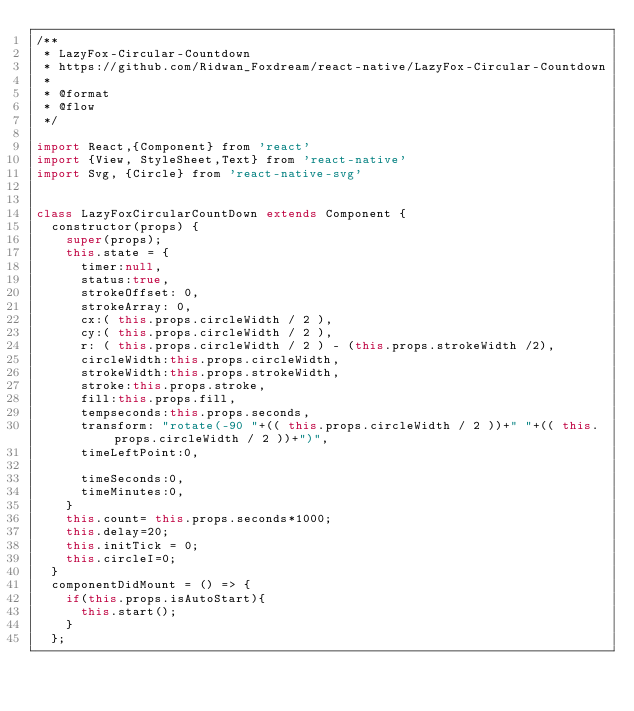<code> <loc_0><loc_0><loc_500><loc_500><_JavaScript_>/**
 * LazyFox-Circular-Countdown
 * https://github.com/Ridwan_Foxdream/react-native/LazyFox-Circular-Countdown
 *
 * @format
 * @flow
 */

import React,{Component} from 'react'
import {View, StyleSheet,Text} from 'react-native'
import Svg, {Circle} from 'react-native-svg'


class LazyFoxCircularCountDown extends Component {
  constructor(props) {
    super(props);
    this.state = {
      timer:null,
      status:true,
      strokeOffset: 0,
      strokeArray: 0,
      cx:( this.props.circleWidth / 2 ),
      cy:( this.props.circleWidth / 2 ),
      r: ( this.props.circleWidth / 2 ) - (this.props.strokeWidth /2),
      circleWidth:this.props.circleWidth,
      strokeWidth:this.props.strokeWidth,
      stroke:this.props.stroke,
      fill:this.props.fill,
      tempseconds:this.props.seconds,
      transform: "rotate(-90 "+(( this.props.circleWidth / 2 ))+" "+(( this.props.circleWidth / 2 ))+")",
      timeLeftPoint:0,

      timeSeconds:0,
      timeMinutes:0,
    }
    this.count= this.props.seconds*1000;
    this.delay=20;
    this.initTick = 0;
    this.circleI=0;
  }
  componentDidMount = () => {
    if(this.props.isAutoStart){
      this.start();
    }
  };</code> 